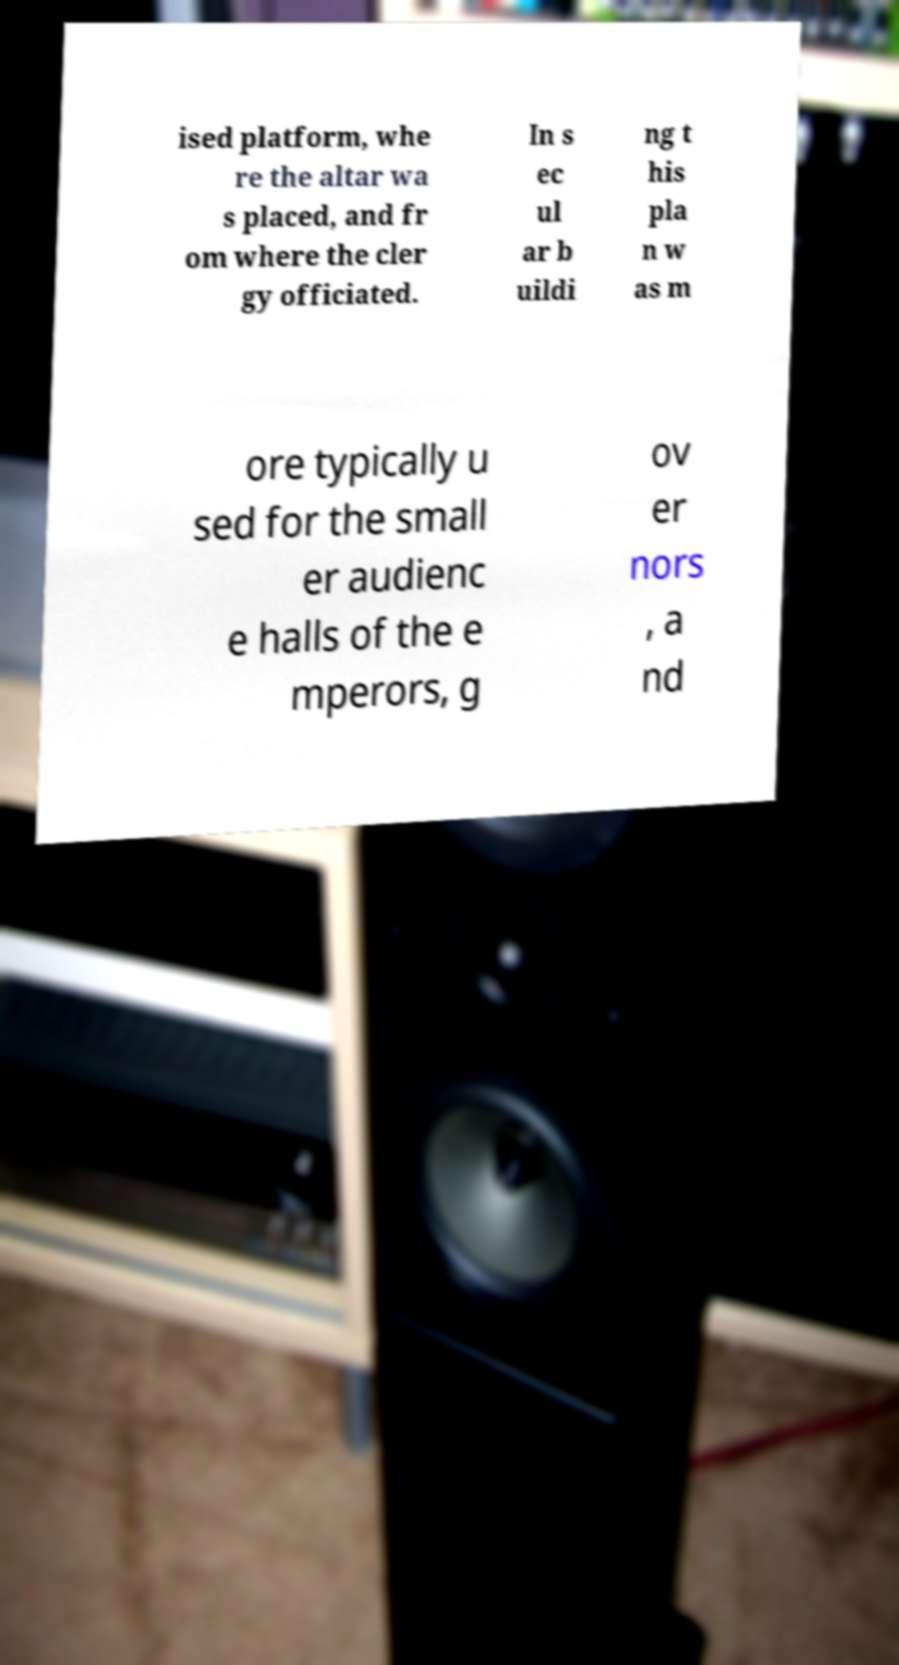Can you read and provide the text displayed in the image?This photo seems to have some interesting text. Can you extract and type it out for me? ised platform, whe re the altar wa s placed, and fr om where the cler gy officiated. In s ec ul ar b uildi ng t his pla n w as m ore typically u sed for the small er audienc e halls of the e mperors, g ov er nors , a nd 